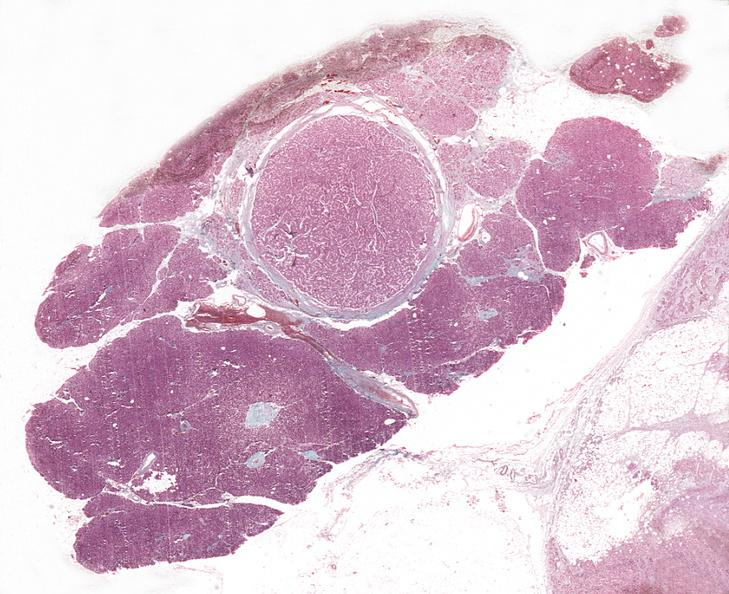where is this?
Answer the question using a single word or phrase. Pancreas 